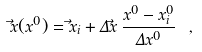Convert formula to latex. <formula><loc_0><loc_0><loc_500><loc_500>\vec { x } ( x ^ { 0 } ) = \vec { x } _ { i } + \Delta \vec { x } \, \frac { x ^ { 0 } - x _ { i } ^ { 0 } } { \Delta x ^ { 0 } } \ ,</formula> 